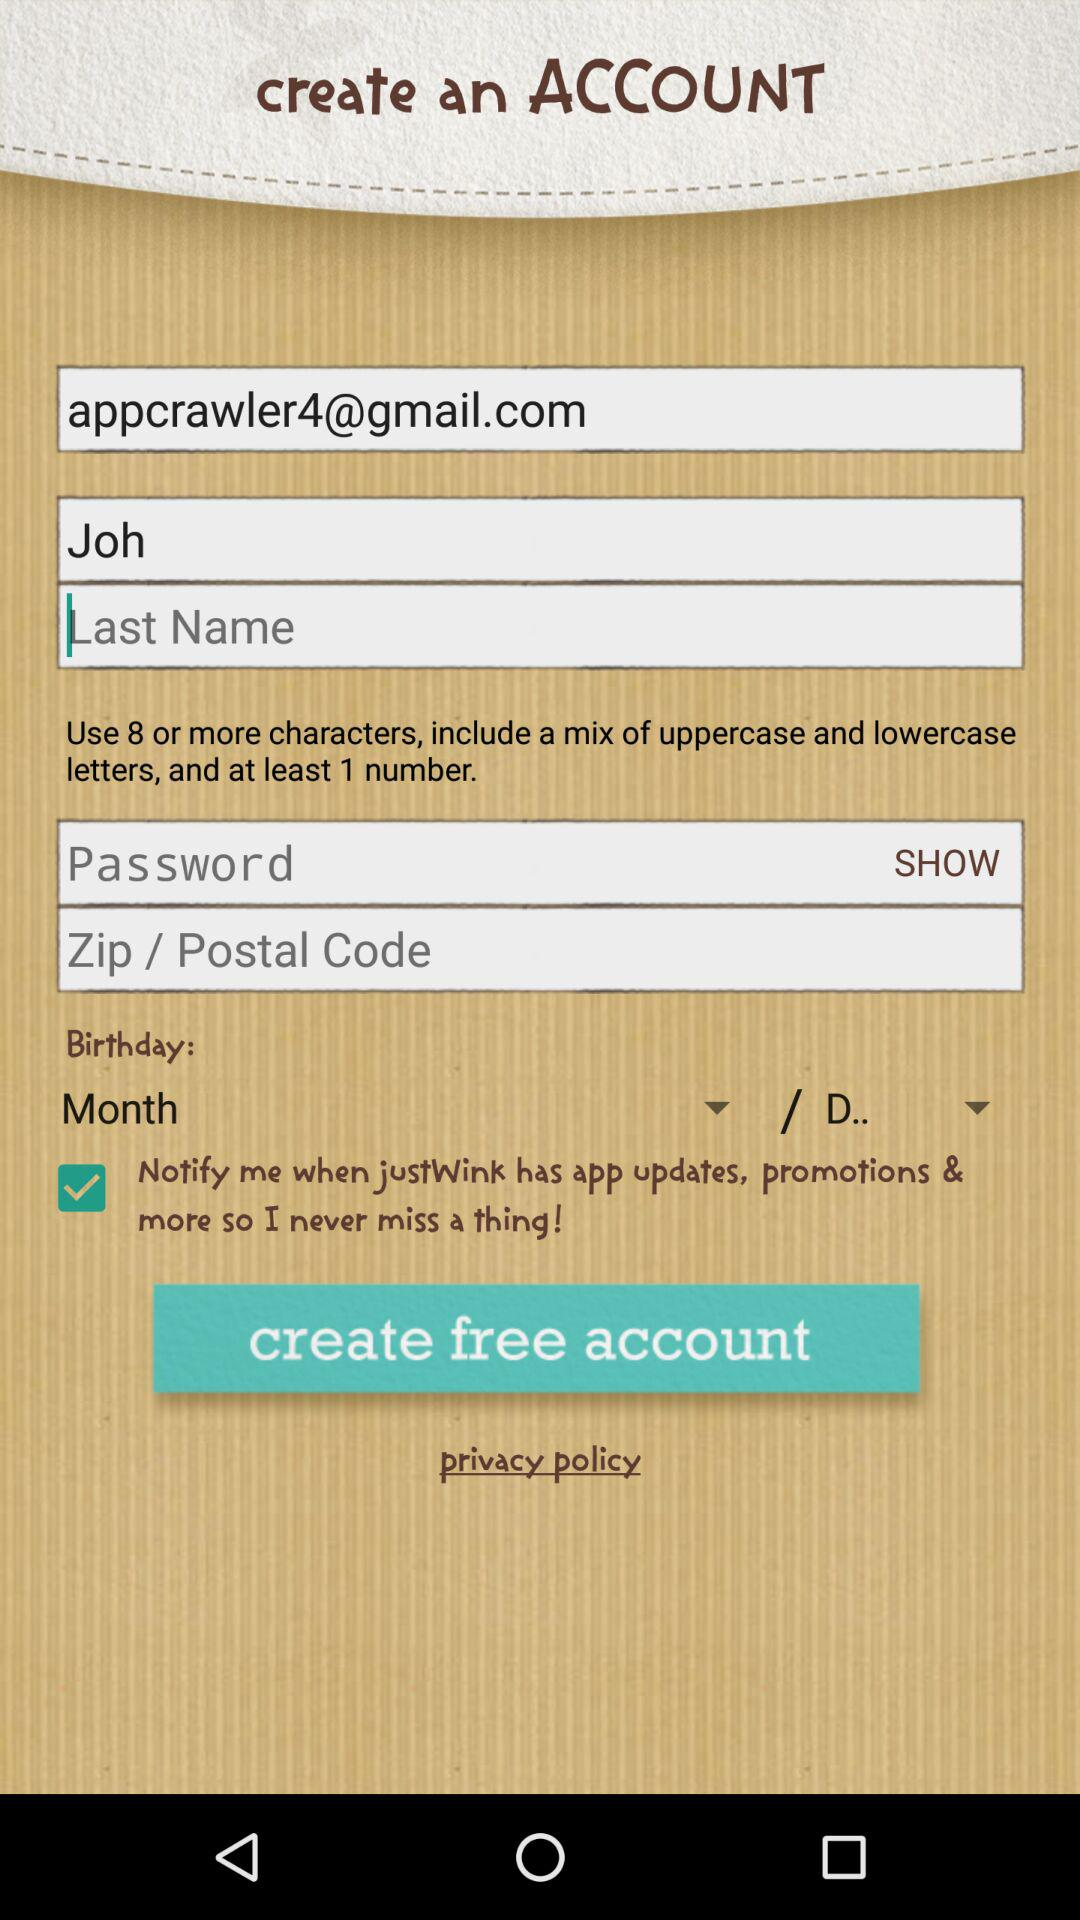What is the email address? The email address is appcrawler4@gmail.com. 